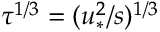Convert formula to latex. <formula><loc_0><loc_0><loc_500><loc_500>\tau ^ { 1 / 3 } = ( u _ { \ast } ^ { 2 } / s ) ^ { 1 / 3 }</formula> 